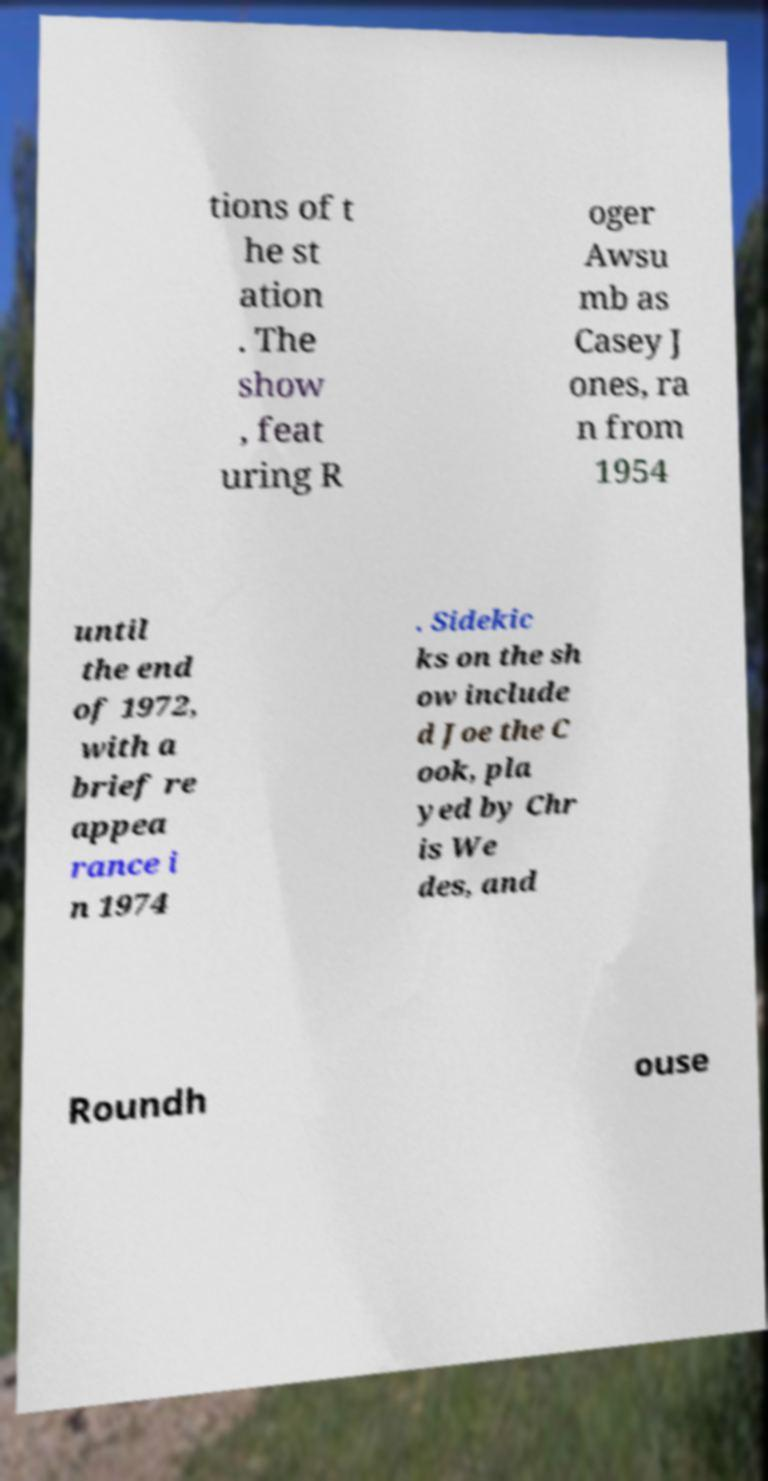Can you accurately transcribe the text from the provided image for me? tions of t he st ation . The show , feat uring R oger Awsu mb as Casey J ones, ra n from 1954 until the end of 1972, with a brief re appea rance i n 1974 . Sidekic ks on the sh ow include d Joe the C ook, pla yed by Chr is We des, and Roundh ouse 